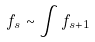Convert formula to latex. <formula><loc_0><loc_0><loc_500><loc_500>f _ { s } \sim \int f _ { s + 1 }</formula> 